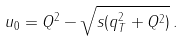<formula> <loc_0><loc_0><loc_500><loc_500>u _ { 0 } = Q ^ { 2 } - \sqrt { s ( q _ { T } ^ { 2 } + Q ^ { 2 } ) } \, .</formula> 